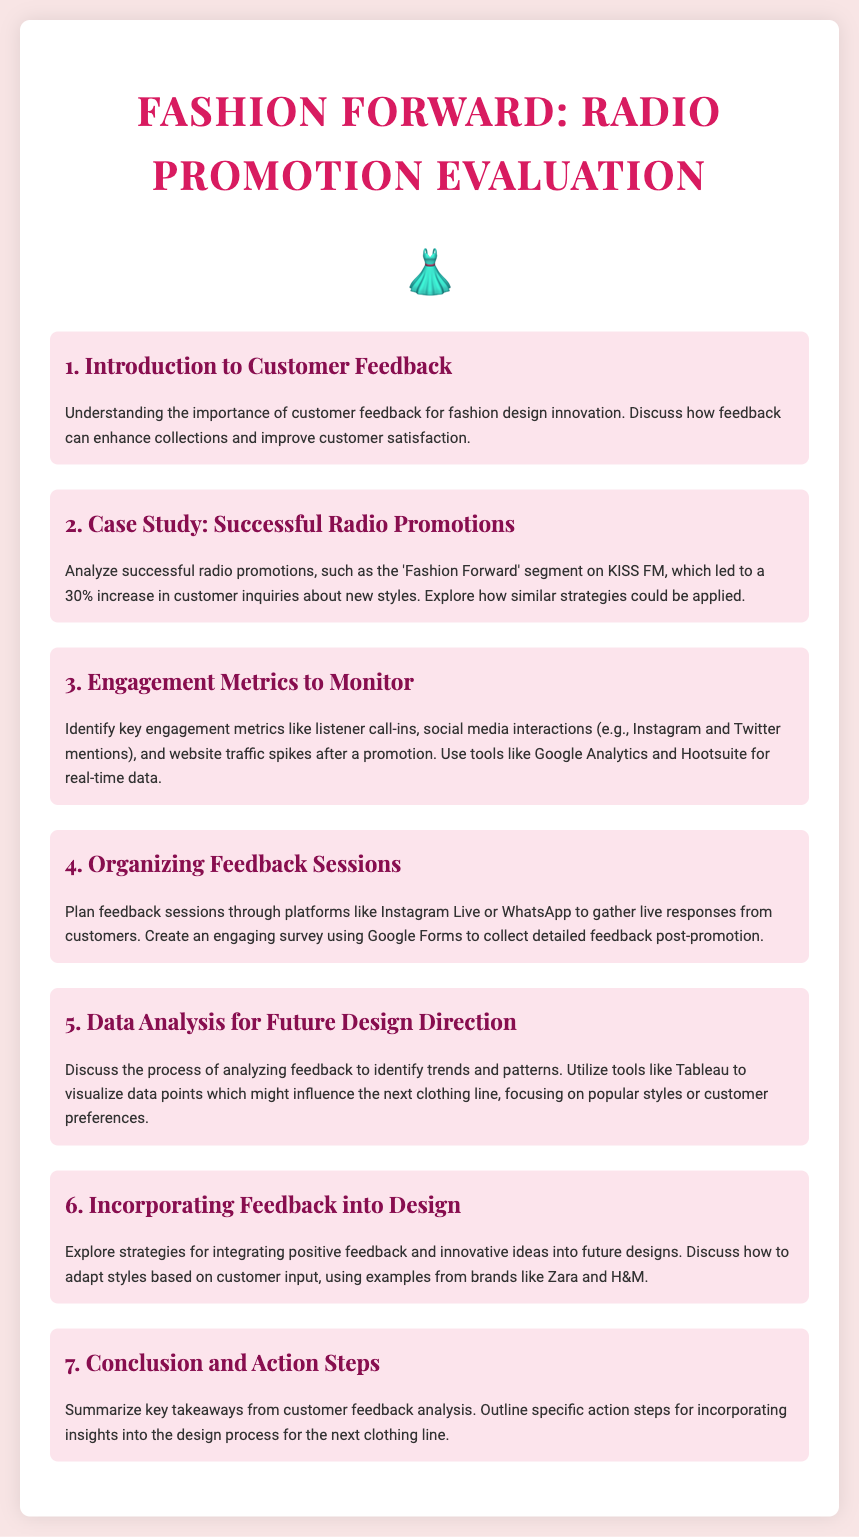What is the title of the document? The title of the document is stated in the header of the agenda.
Answer: Fashion Forward: Radio Promotion Evaluation How many agenda items are there? The number of agenda items can be counted in the document.
Answer: 7 What increase in customer inquiries was noted in the case study? The specific percentage increase in customer inquiries is mentioned in the case study.
Answer: 30% What tools are suggested for analyzing engagement metrics? The document lists tools that can be used for monitoring engagement metrics.
Answer: Google Analytics and Hootsuite Which platform is mentioned for organizing feedback sessions? The platform that can be used for feedback sessions is specified in the document.
Answer: Instagram Live What is the focus of the data analysis discussed in item 5? The focus of the data analysis is detailed in the agenda item description.
Answer: Trends and patterns Which brands are referenced as examples for incorporating feedback into design? The document mentions specific brands that exemplify the integration of feedback.
Answer: Zara and H&M 